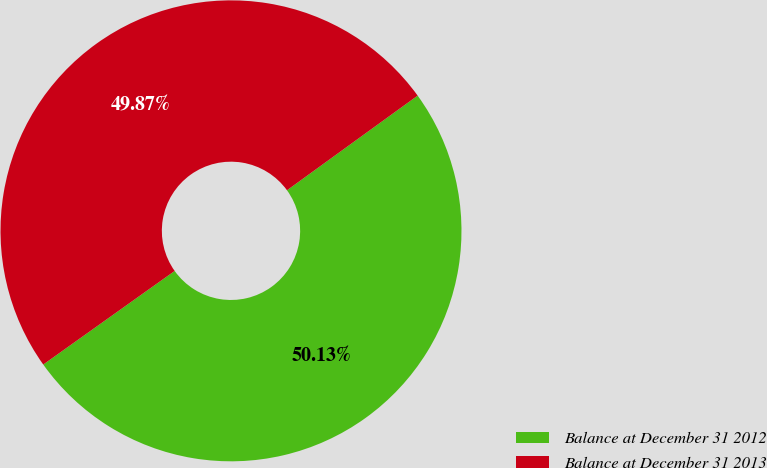Convert chart. <chart><loc_0><loc_0><loc_500><loc_500><pie_chart><fcel>Balance at December 31 2012<fcel>Balance at December 31 2013<nl><fcel>50.13%<fcel>49.87%<nl></chart> 